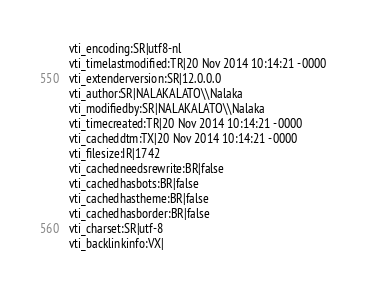Convert code to text. <code><loc_0><loc_0><loc_500><loc_500><_PHP_>vti_encoding:SR|utf8-nl
vti_timelastmodified:TR|20 Nov 2014 10:14:21 -0000
vti_extenderversion:SR|12.0.0.0
vti_author:SR|NALAKALATO\\Nalaka
vti_modifiedby:SR|NALAKALATO\\Nalaka
vti_timecreated:TR|20 Nov 2014 10:14:21 -0000
vti_cacheddtm:TX|20 Nov 2014 10:14:21 -0000
vti_filesize:IR|1742
vti_cachedneedsrewrite:BR|false
vti_cachedhasbots:BR|false
vti_cachedhastheme:BR|false
vti_cachedhasborder:BR|false
vti_charset:SR|utf-8
vti_backlinkinfo:VX|
</code> 